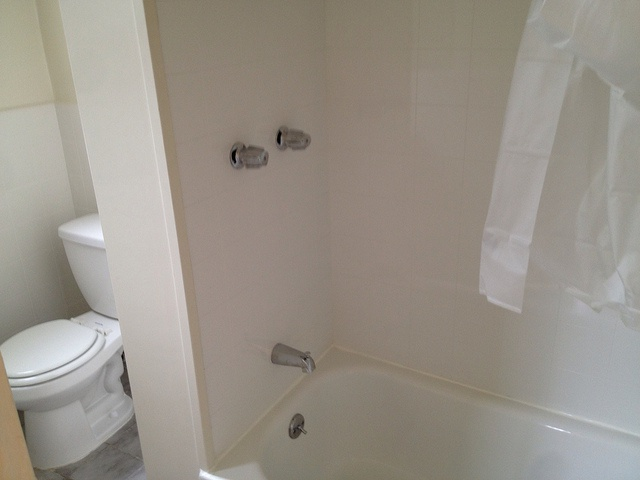Describe the objects in this image and their specific colors. I can see a toilet in darkgray, lightgray, and gray tones in this image. 